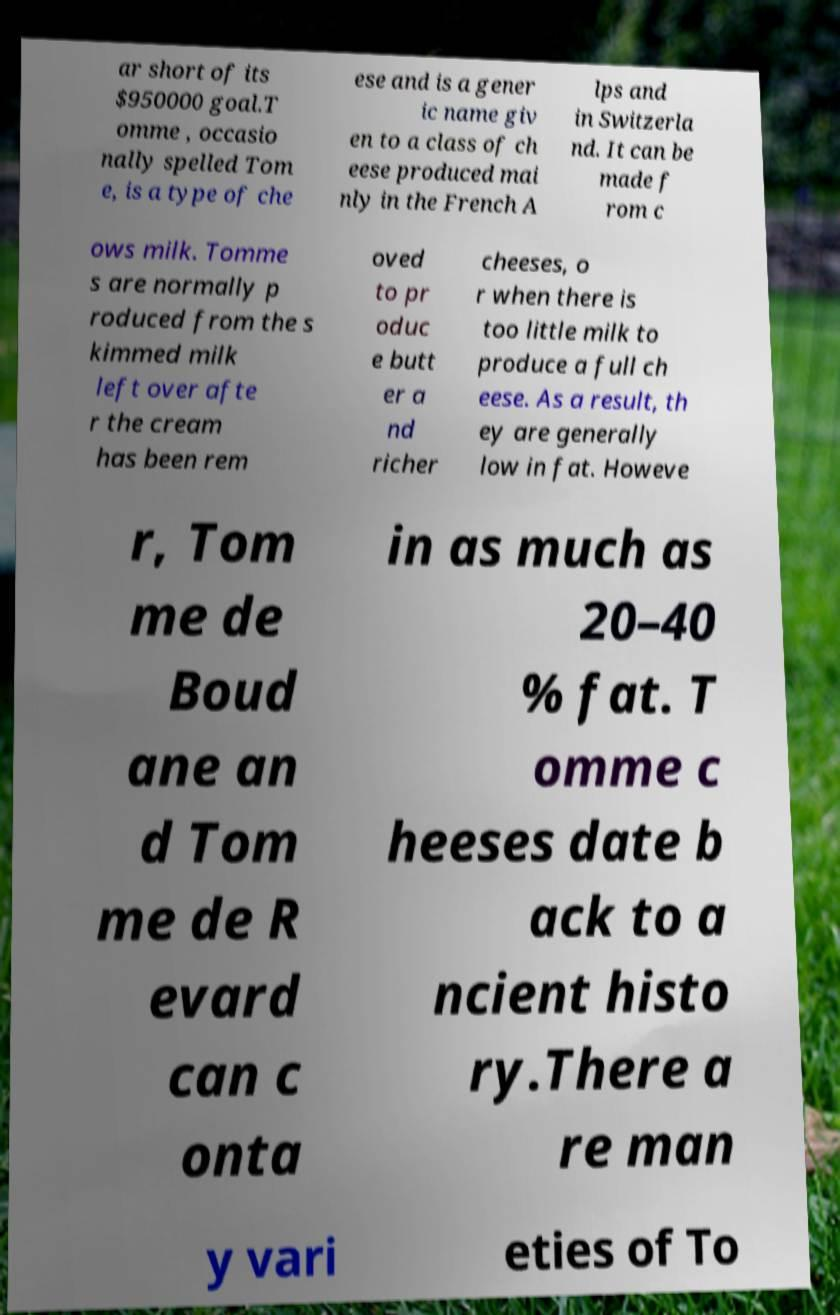Can you read and provide the text displayed in the image?This photo seems to have some interesting text. Can you extract and type it out for me? ar short of its $950000 goal.T omme , occasio nally spelled Tom e, is a type of che ese and is a gener ic name giv en to a class of ch eese produced mai nly in the French A lps and in Switzerla nd. It can be made f rom c ows milk. Tomme s are normally p roduced from the s kimmed milk left over afte r the cream has been rem oved to pr oduc e butt er a nd richer cheeses, o r when there is too little milk to produce a full ch eese. As a result, th ey are generally low in fat. Howeve r, Tom me de Boud ane an d Tom me de R evard can c onta in as much as 20–40 % fat. T omme c heeses date b ack to a ncient histo ry.There a re man y vari eties of To 